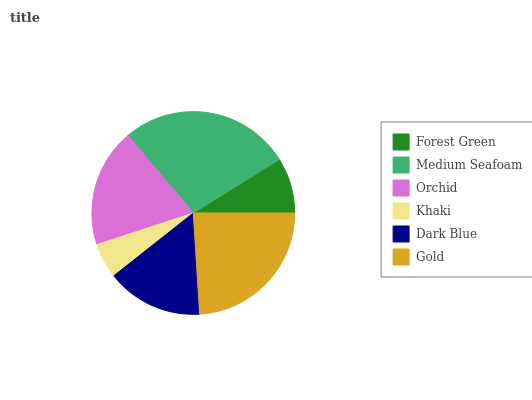Is Khaki the minimum?
Answer yes or no. Yes. Is Medium Seafoam the maximum?
Answer yes or no. Yes. Is Orchid the minimum?
Answer yes or no. No. Is Orchid the maximum?
Answer yes or no. No. Is Medium Seafoam greater than Orchid?
Answer yes or no. Yes. Is Orchid less than Medium Seafoam?
Answer yes or no. Yes. Is Orchid greater than Medium Seafoam?
Answer yes or no. No. Is Medium Seafoam less than Orchid?
Answer yes or no. No. Is Orchid the high median?
Answer yes or no. Yes. Is Dark Blue the low median?
Answer yes or no. Yes. Is Dark Blue the high median?
Answer yes or no. No. Is Forest Green the low median?
Answer yes or no. No. 